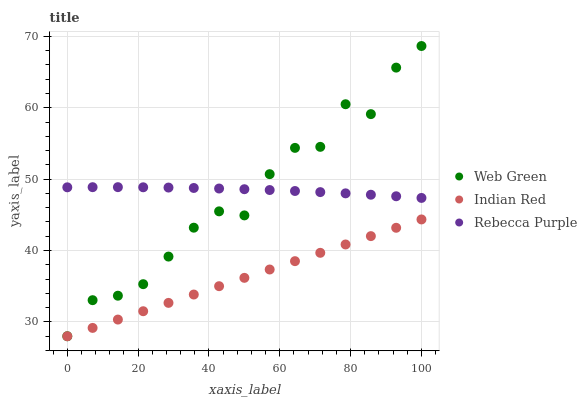Does Indian Red have the minimum area under the curve?
Answer yes or no. Yes. Does Rebecca Purple have the maximum area under the curve?
Answer yes or no. Yes. Does Web Green have the minimum area under the curve?
Answer yes or no. No. Does Web Green have the maximum area under the curve?
Answer yes or no. No. Is Indian Red the smoothest?
Answer yes or no. Yes. Is Web Green the roughest?
Answer yes or no. Yes. Is Rebecca Purple the smoothest?
Answer yes or no. No. Is Rebecca Purple the roughest?
Answer yes or no. No. Does Indian Red have the lowest value?
Answer yes or no. Yes. Does Rebecca Purple have the lowest value?
Answer yes or no. No. Does Web Green have the highest value?
Answer yes or no. Yes. Does Rebecca Purple have the highest value?
Answer yes or no. No. Is Indian Red less than Rebecca Purple?
Answer yes or no. Yes. Is Rebecca Purple greater than Indian Red?
Answer yes or no. Yes. Does Web Green intersect Indian Red?
Answer yes or no. Yes. Is Web Green less than Indian Red?
Answer yes or no. No. Is Web Green greater than Indian Red?
Answer yes or no. No. Does Indian Red intersect Rebecca Purple?
Answer yes or no. No. 